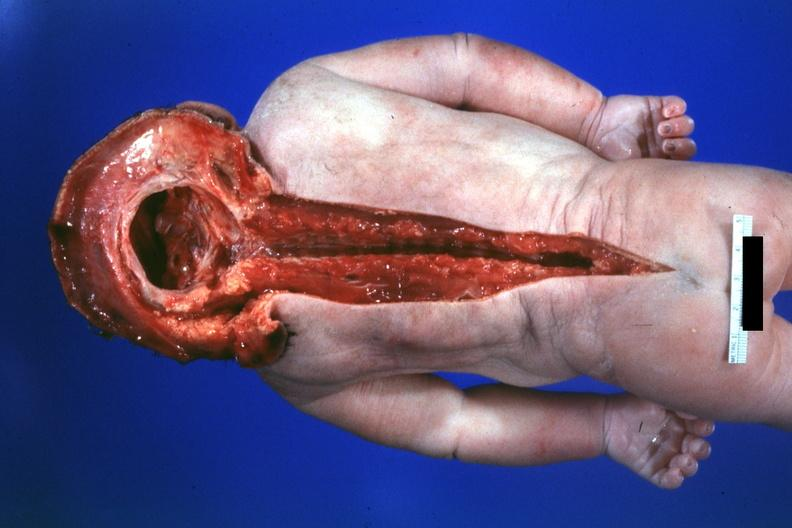s no chromosomal defects lived one day?
Answer the question using a single word or phrase. Yes 